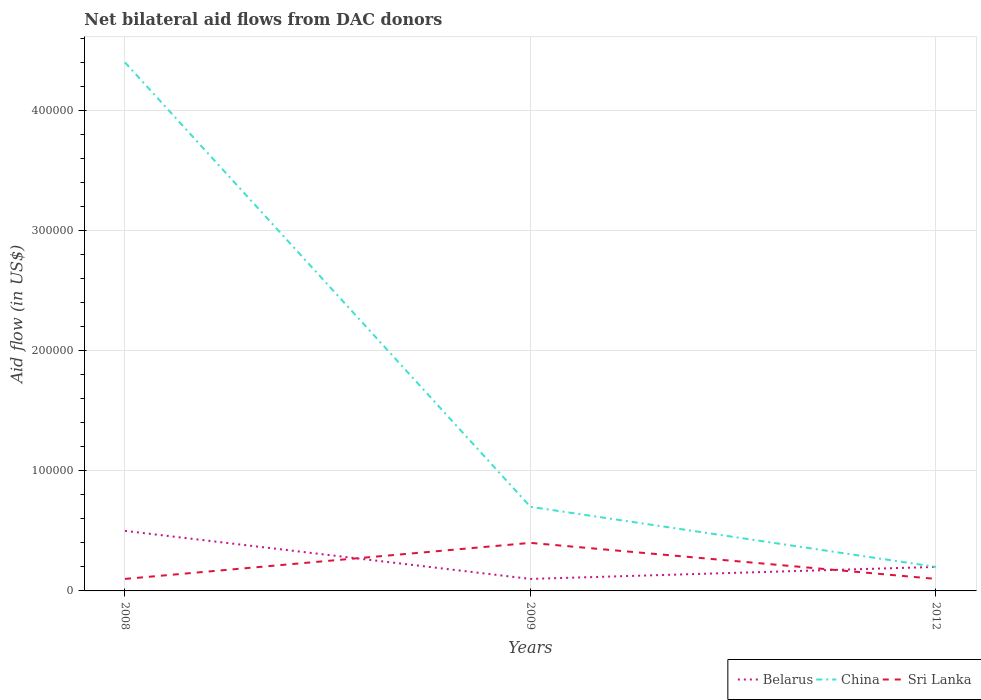How many different coloured lines are there?
Provide a short and direct response. 3. Across all years, what is the maximum net bilateral aid flow in Belarus?
Your answer should be compact. 10000. In which year was the net bilateral aid flow in Belarus maximum?
Your answer should be very brief. 2009. What is the total net bilateral aid flow in Belarus in the graph?
Offer a terse response. -10000. Is the net bilateral aid flow in China strictly greater than the net bilateral aid flow in Belarus over the years?
Provide a succinct answer. No. How many lines are there?
Your answer should be very brief. 3. How many years are there in the graph?
Ensure brevity in your answer.  3. Does the graph contain any zero values?
Your response must be concise. No. How are the legend labels stacked?
Your answer should be compact. Horizontal. What is the title of the graph?
Offer a very short reply. Net bilateral aid flows from DAC donors. Does "Uzbekistan" appear as one of the legend labels in the graph?
Provide a succinct answer. No. What is the label or title of the Y-axis?
Give a very brief answer. Aid flow (in US$). What is the Aid flow (in US$) of China in 2008?
Offer a very short reply. 4.40e+05. What is the Aid flow (in US$) of Belarus in 2009?
Give a very brief answer. 10000. What is the Aid flow (in US$) of Sri Lanka in 2009?
Ensure brevity in your answer.  4.00e+04. What is the Aid flow (in US$) of Belarus in 2012?
Your answer should be very brief. 2.00e+04. What is the Aid flow (in US$) of China in 2012?
Give a very brief answer. 2.00e+04. Across all years, what is the maximum Aid flow (in US$) in Belarus?
Your response must be concise. 5.00e+04. Across all years, what is the maximum Aid flow (in US$) of Sri Lanka?
Offer a terse response. 4.00e+04. Across all years, what is the minimum Aid flow (in US$) in China?
Keep it short and to the point. 2.00e+04. Across all years, what is the minimum Aid flow (in US$) in Sri Lanka?
Make the answer very short. 10000. What is the total Aid flow (in US$) of China in the graph?
Give a very brief answer. 5.30e+05. What is the total Aid flow (in US$) of Sri Lanka in the graph?
Offer a very short reply. 6.00e+04. What is the difference between the Aid flow (in US$) of Belarus in 2008 and that in 2009?
Keep it short and to the point. 4.00e+04. What is the difference between the Aid flow (in US$) of China in 2008 and that in 2009?
Offer a very short reply. 3.70e+05. What is the difference between the Aid flow (in US$) of Sri Lanka in 2008 and that in 2009?
Offer a very short reply. -3.00e+04. What is the difference between the Aid flow (in US$) of China in 2008 and that in 2012?
Offer a terse response. 4.20e+05. What is the difference between the Aid flow (in US$) in Sri Lanka in 2008 and that in 2012?
Provide a succinct answer. 0. What is the difference between the Aid flow (in US$) in Belarus in 2009 and that in 2012?
Provide a short and direct response. -10000. What is the difference between the Aid flow (in US$) of China in 2009 and that in 2012?
Offer a very short reply. 5.00e+04. What is the difference between the Aid flow (in US$) of Sri Lanka in 2009 and that in 2012?
Your response must be concise. 3.00e+04. What is the difference between the Aid flow (in US$) of China in 2008 and the Aid flow (in US$) of Sri Lanka in 2009?
Offer a terse response. 4.00e+05. What is the difference between the Aid flow (in US$) of Belarus in 2008 and the Aid flow (in US$) of Sri Lanka in 2012?
Offer a very short reply. 4.00e+04. What is the difference between the Aid flow (in US$) of China in 2008 and the Aid flow (in US$) of Sri Lanka in 2012?
Your answer should be compact. 4.30e+05. What is the difference between the Aid flow (in US$) of China in 2009 and the Aid flow (in US$) of Sri Lanka in 2012?
Ensure brevity in your answer.  6.00e+04. What is the average Aid flow (in US$) of Belarus per year?
Provide a succinct answer. 2.67e+04. What is the average Aid flow (in US$) in China per year?
Your response must be concise. 1.77e+05. In the year 2008, what is the difference between the Aid flow (in US$) of Belarus and Aid flow (in US$) of China?
Offer a terse response. -3.90e+05. In the year 2008, what is the difference between the Aid flow (in US$) of Belarus and Aid flow (in US$) of Sri Lanka?
Keep it short and to the point. 4.00e+04. In the year 2009, what is the difference between the Aid flow (in US$) in Belarus and Aid flow (in US$) in China?
Your response must be concise. -6.00e+04. In the year 2009, what is the difference between the Aid flow (in US$) in Belarus and Aid flow (in US$) in Sri Lanka?
Ensure brevity in your answer.  -3.00e+04. In the year 2009, what is the difference between the Aid flow (in US$) of China and Aid flow (in US$) of Sri Lanka?
Provide a short and direct response. 3.00e+04. What is the ratio of the Aid flow (in US$) of Belarus in 2008 to that in 2009?
Make the answer very short. 5. What is the ratio of the Aid flow (in US$) in China in 2008 to that in 2009?
Give a very brief answer. 6.29. What is the ratio of the Aid flow (in US$) of Sri Lanka in 2008 to that in 2009?
Provide a succinct answer. 0.25. What is the ratio of the Aid flow (in US$) in Belarus in 2008 to that in 2012?
Offer a very short reply. 2.5. What is the ratio of the Aid flow (in US$) of China in 2008 to that in 2012?
Your answer should be very brief. 22. What is the ratio of the Aid flow (in US$) of Sri Lanka in 2009 to that in 2012?
Give a very brief answer. 4. What is the difference between the highest and the second highest Aid flow (in US$) of Belarus?
Provide a succinct answer. 3.00e+04. What is the difference between the highest and the second highest Aid flow (in US$) in China?
Give a very brief answer. 3.70e+05. What is the difference between the highest and the lowest Aid flow (in US$) in China?
Offer a very short reply. 4.20e+05. What is the difference between the highest and the lowest Aid flow (in US$) of Sri Lanka?
Your response must be concise. 3.00e+04. 